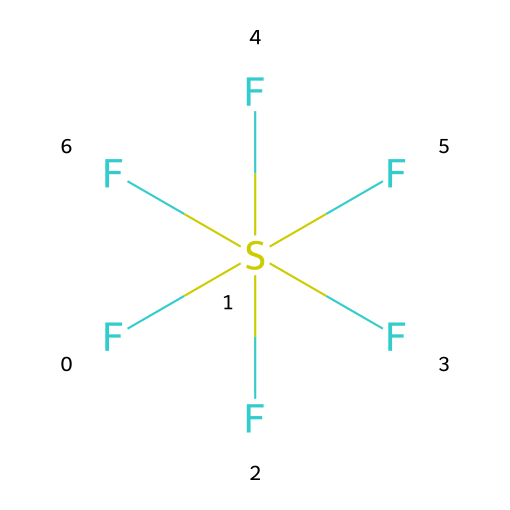What is the name of this chemical? The chemical structure provided corresponds to sulfur hexafluoride, as its formula is SF6. The "S" denotes sulfur and the "F" indicates the presence of fluorine atoms.
Answer: sulfur hexafluoride How many fluorine atoms are present in this molecule? By analyzing the SMILES representation, it shows "F" six times attached to a single sulfur atom, indicating there are six fluorine atoms.
Answer: six What is the central atom in this molecule? The SMILES representation indicates "S" is present, which stands for sulfur. This atom is the central atom of the molecule, surrounded by fluorine atoms.
Answer: sulfur Is sulfur hexafluoride polar or nonpolar? The molecule's symmetrical structure, with identical fluorine atoms around the central sulfur atom, suggests even distribution of charge, resulting in a nonpolar molecule.
Answer: nonpolar What type of bonding exists in sulfur hexafluoride? The bonds between the sulfur and fluorine atoms are covalent bonds, as they share electrons. This is evident from the structure where fluorine is bonded to sulfur.
Answer: covalent How many total atoms are in the sulfur hexafluoride molecule? The molecule has six fluorine atoms and one sulfur atom. Adding these together gives a total of seven atoms in the sulfur hexafluoride molecule.
Answer: seven What type of compound is sulfur hexafluoride categorized as? Sulfur hexafluoride is categorized as a gas, specifically a synthetic gas used in various applications, including the detection of volcanic gases.
Answer: gas 